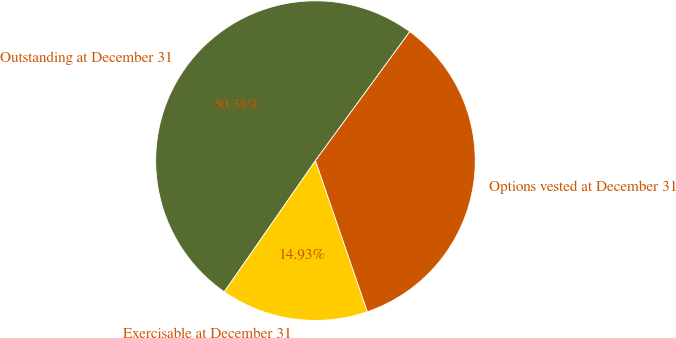Convert chart to OTSL. <chart><loc_0><loc_0><loc_500><loc_500><pie_chart><fcel>Outstanding at December 31<fcel>Exercisable at December 31<fcel>Options vested at December 31<nl><fcel>50.38%<fcel>14.93%<fcel>34.69%<nl></chart> 